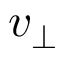Convert formula to latex. <formula><loc_0><loc_0><loc_500><loc_500>v _ { \perp }</formula> 